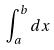Convert formula to latex. <formula><loc_0><loc_0><loc_500><loc_500>\int _ { a } ^ { b } d x</formula> 